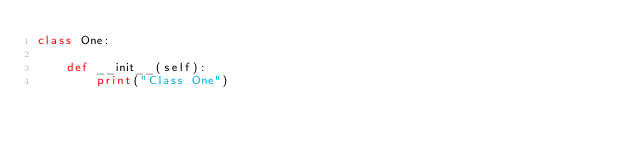Convert code to text. <code><loc_0><loc_0><loc_500><loc_500><_Python_>class One:

    def __init__(self):
        print("Class One")
</code> 